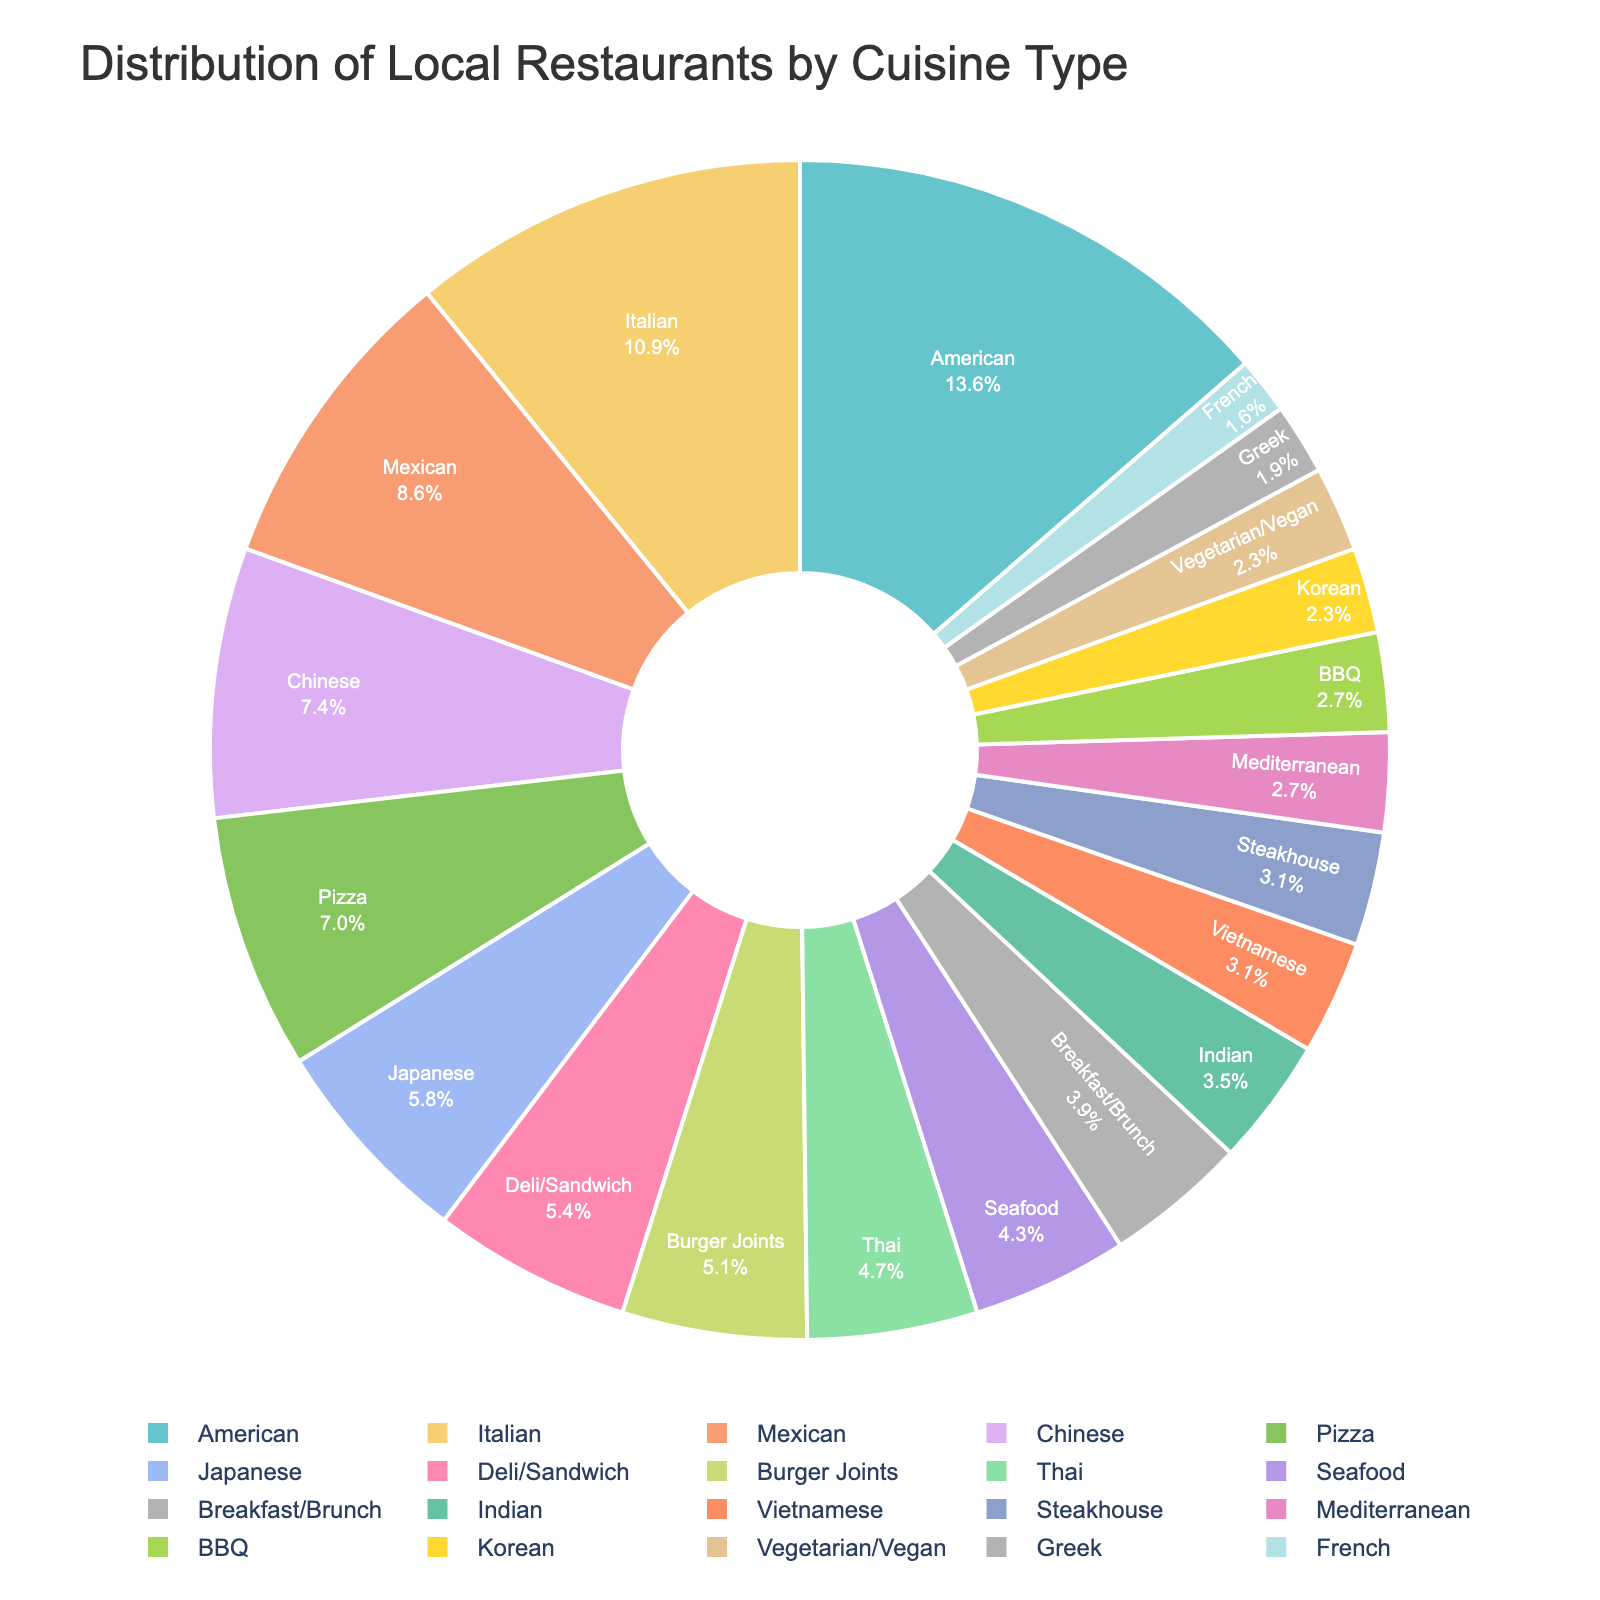What percentage of the local restaurants are Italian? To find the percentage of Italian restaurants, divide the number of Italian restaurants (28) by the total number of restaurants listed. Then multiply by 100 to get the percentage: (28 / 261) * 100 ≈ 10.7%
Answer: 10.7% Which cuisine type has the highest number of restaurants, and how many restaurants are there of that type? Look at the pie chart to identify the largest segment, which represents the American cuisine type. The number of restaurants in this type is indicated directly in the chart: 35
Answer: American, 35 Are there more Mexican or Chinese restaurants? Compare the number of Mexican restaurants (22) to Chinese restaurants (19). The segment representing Mexican restaurants is larger in the pie chart
Answer: Mexican What is the combined percentage of Japanese and Korean restaurants? First, find the number of Japanese (15) and Korean (6) restaurants, then sum them up: 15 + 6 = 21. Next, divide by the total number of restaurants (261) and multiply by 100: (21 / 261) * 100 ≈ 8.0%
Answer: 8.0% What percentage of restaurants serve either Thai or Indian cuisine? Add the number of Thai (12) and Indian (9) restaurants to get 21. Then divide by the total number of restaurants (261) and multiply by 100: (21 / 261) * 100 ≈ 8.0%
Answer: 8.0% Is the number of Vietnamese restaurants greater than the number of Seafood restaurants? Compare the number of Vietnamese restaurants (8) to Seafood restaurants (11). The segment representing Seafood is larger in the pie chart
Answer: No Which cuisine type has the smallest representation in terms of the number of restaurants? Look for the smallest segment in the pie chart, which represents the French cuisine type with 4 restaurants
Answer: French, 4 How many more Burger Joints are there compared to Deli/Sandwich restaurants? Find the number of Burger Joints (13) and Deli/Sandwich restaurants (14), then subtract the smaller number from the larger one: 13 - 14 = -1 (indicating that there is 1 less Burger Joint)
Answer: 1 less What is the absolute difference in the number of American and Italian restaurants? Subtract the number of Italian restaurants (28) from the number of American restaurants (35): 35 - 28 = 7
Answer: 7 What fraction of the restaurants serve either Breakfast/Brunch or Burgers? Add the number of Breakfast/Brunch (10) and Burger Joints (13) restaurants to get 23. Then express this as a fraction of the total number of restaurants (261): 23 / 261 ≈ 1/11.35
Answer: 1/11.35 